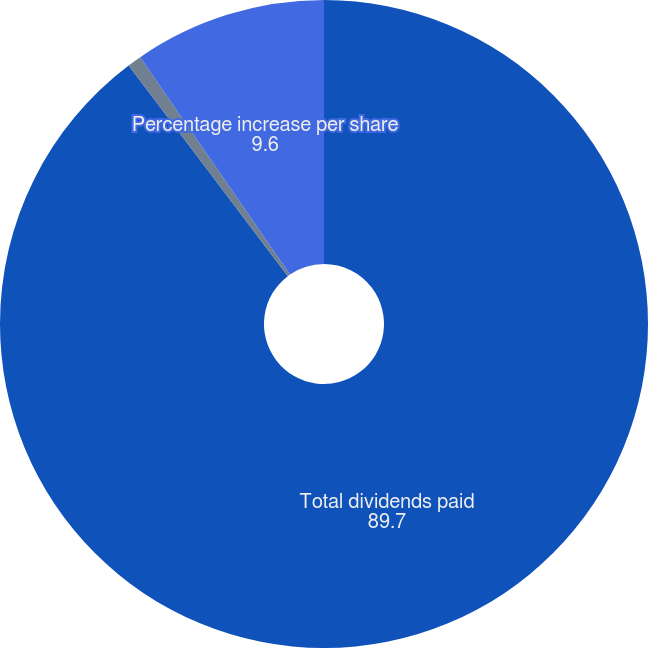Convert chart. <chart><loc_0><loc_0><loc_500><loc_500><pie_chart><fcel>Total dividends paid<fcel>Dividends paid per share<fcel>Percentage increase per share<nl><fcel>89.7%<fcel>0.7%<fcel>9.6%<nl></chart> 